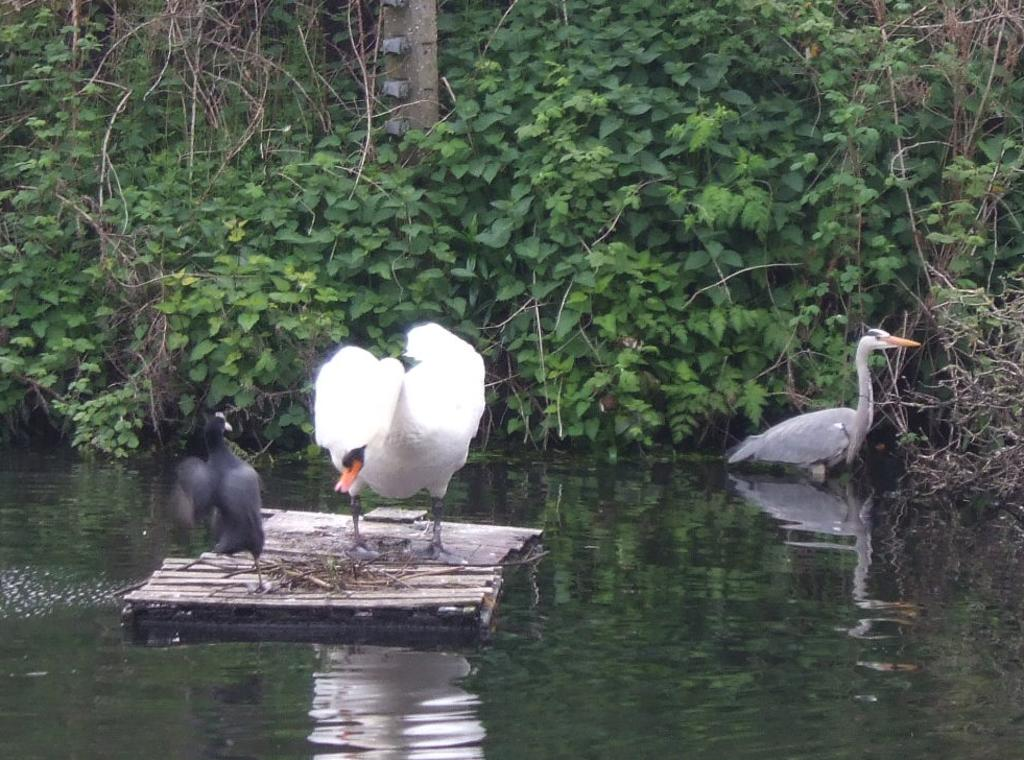What type of animals are in the image? There are swans in the image. What colors are the swans? The swans are in white and black colors. What is at the bottom of the image? There is water at the bottom of the image. What can be seen in the background of the image? There are plants and trees in the background of the image. What type of chalk is being used by the police in the image? There are no police or chalk present in the image; it features swans in water with plants and trees in the background. 